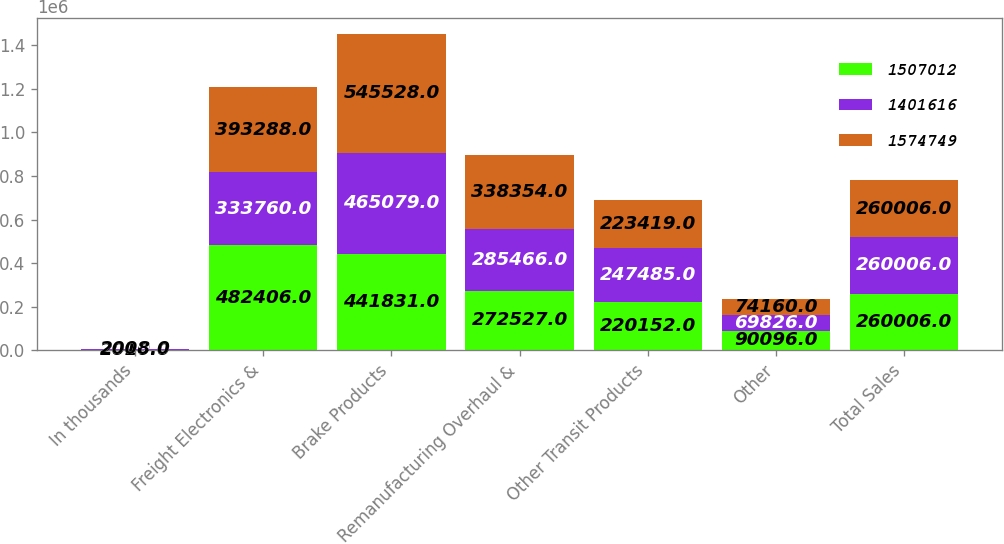Convert chart to OTSL. <chart><loc_0><loc_0><loc_500><loc_500><stacked_bar_chart><ecel><fcel>In thousands<fcel>Freight Electronics &<fcel>Brake Products<fcel>Remanufacturing Overhaul &<fcel>Other Transit Products<fcel>Other<fcel>Total Sales<nl><fcel>1.50701e+06<fcel>2010<fcel>482406<fcel>441831<fcel>272527<fcel>220152<fcel>90096<fcel>260006<nl><fcel>1.40162e+06<fcel>2009<fcel>333760<fcel>465079<fcel>285466<fcel>247485<fcel>69826<fcel>260006<nl><fcel>1.57475e+06<fcel>2008<fcel>393288<fcel>545528<fcel>338354<fcel>223419<fcel>74160<fcel>260006<nl></chart> 